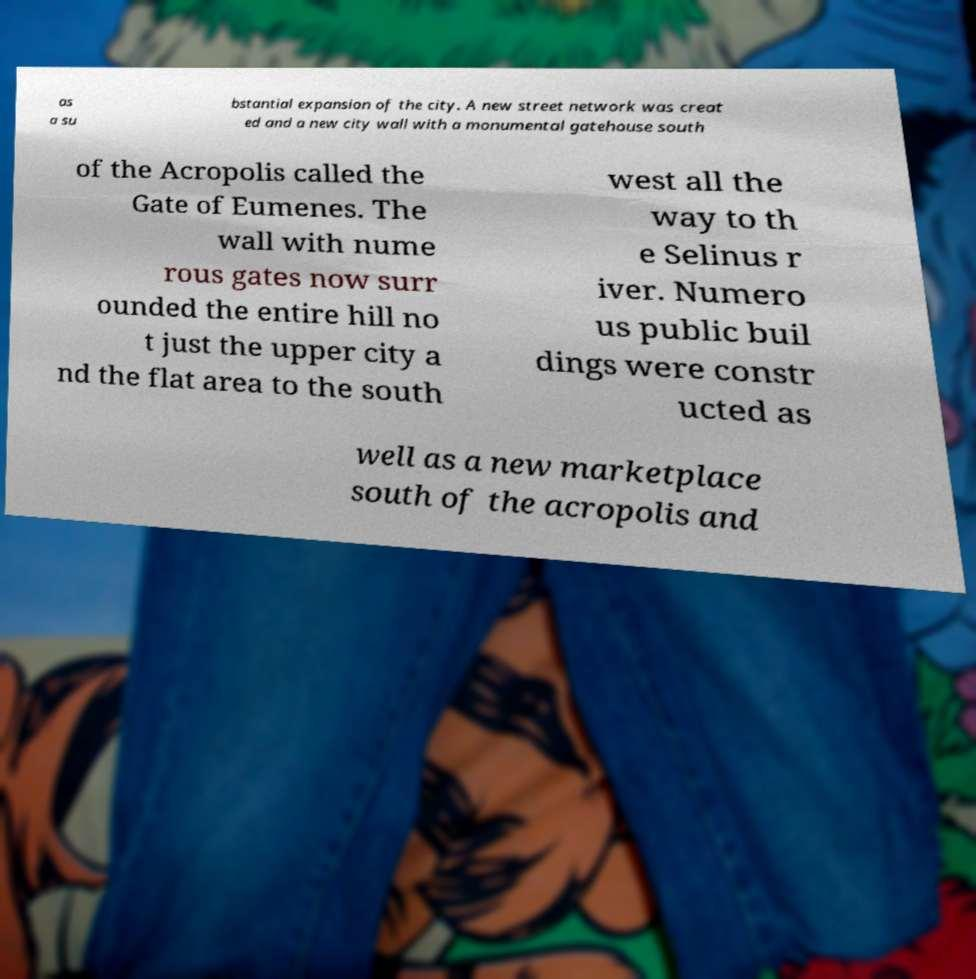Please identify and transcribe the text found in this image. as a su bstantial expansion of the city. A new street network was creat ed and a new city wall with a monumental gatehouse south of the Acropolis called the Gate of Eumenes. The wall with nume rous gates now surr ounded the entire hill no t just the upper city a nd the flat area to the south west all the way to th e Selinus r iver. Numero us public buil dings were constr ucted as well as a new marketplace south of the acropolis and 